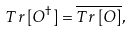Convert formula to latex. <formula><loc_0><loc_0><loc_500><loc_500>T r \, [ O ^ { \dagger } ] = { \overline { T r \, [ O ] } } ,</formula> 